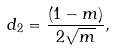<formula> <loc_0><loc_0><loc_500><loc_500>d _ { 2 } = \frac { \left ( 1 - m \right ) } { 2 \sqrt { m } } ,</formula> 